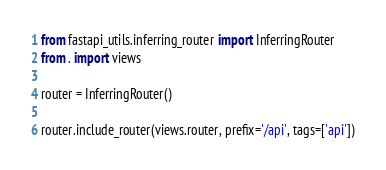<code> <loc_0><loc_0><loc_500><loc_500><_Python_>from fastapi_utils.inferring_router import InferringRouter
from . import views

router = InferringRouter()

router.include_router(views.router, prefix='/api', tags=['api'])
</code> 